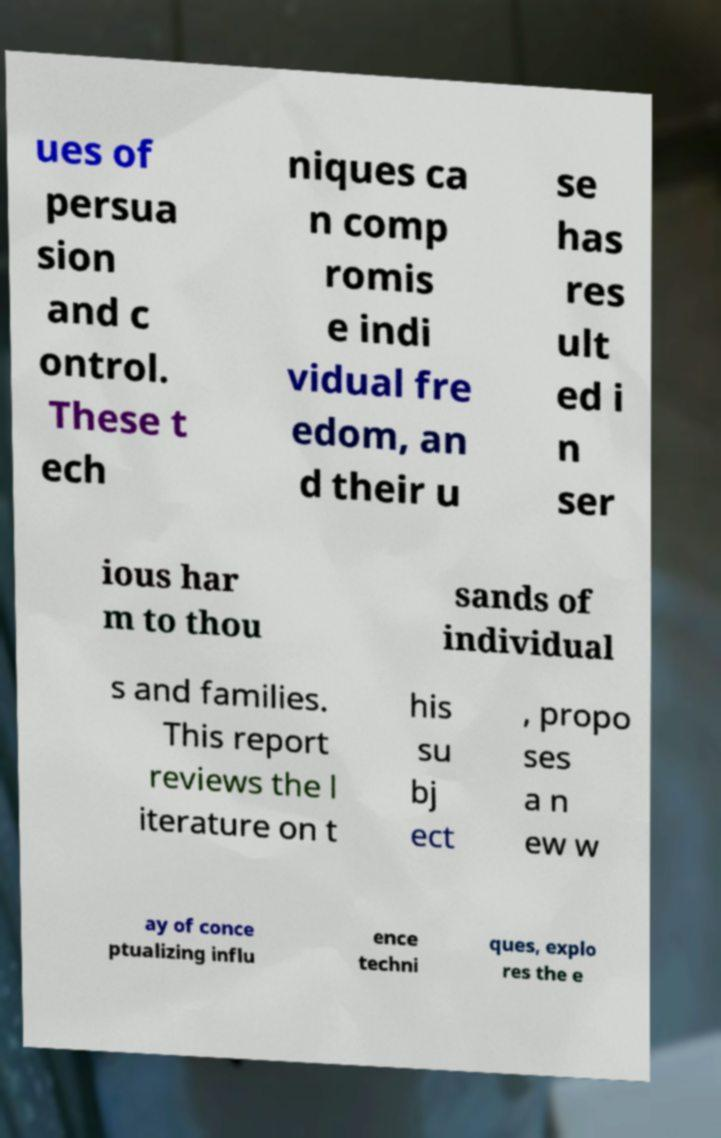Could you assist in decoding the text presented in this image and type it out clearly? ues of persua sion and c ontrol. These t ech niques ca n comp romis e indi vidual fre edom, an d their u se has res ult ed i n ser ious har m to thou sands of individual s and families. This report reviews the l iterature on t his su bj ect , propo ses a n ew w ay of conce ptualizing influ ence techni ques, explo res the e 